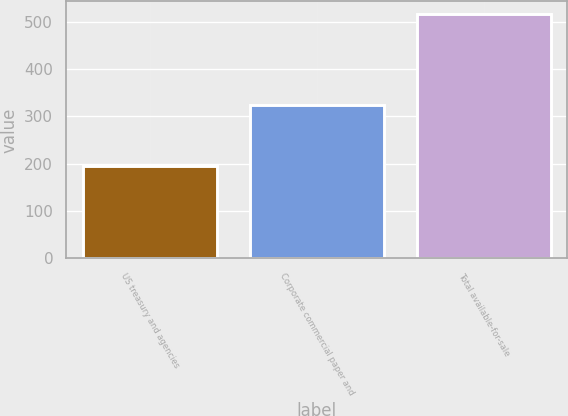<chart> <loc_0><loc_0><loc_500><loc_500><bar_chart><fcel>US treasury and agencies<fcel>Corporate commercial paper and<fcel>Total available-for-sale<nl><fcel>194.1<fcel>323.2<fcel>517.3<nl></chart> 